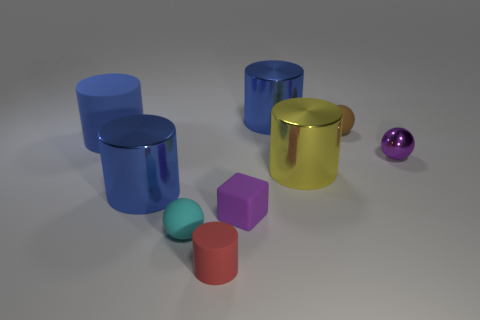Add 1 red rubber cylinders. How many objects exist? 10 Subtract all tiny rubber balls. How many balls are left? 1 Subtract all blocks. How many objects are left? 8 Subtract all brown balls. How many blue cylinders are left? 3 Subtract all blue cylinders. How many cylinders are left? 2 Subtract 1 balls. How many balls are left? 2 Subtract all red matte objects. Subtract all small matte balls. How many objects are left? 6 Add 4 blue things. How many blue things are left? 7 Add 6 large matte cylinders. How many large matte cylinders exist? 7 Subtract 0 blue cubes. How many objects are left? 9 